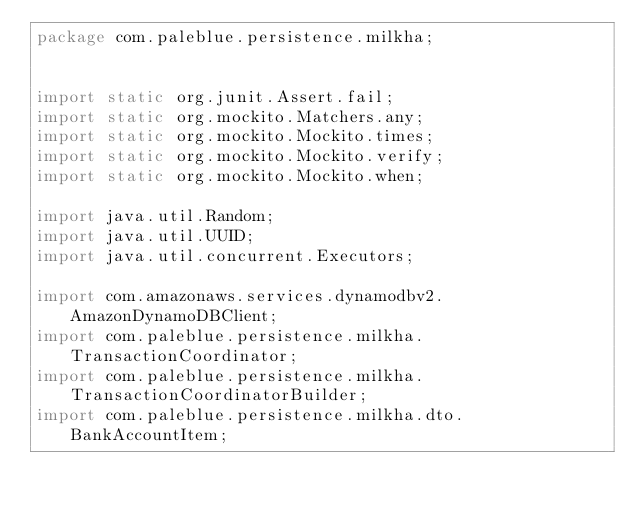<code> <loc_0><loc_0><loc_500><loc_500><_Java_>package com.paleblue.persistence.milkha;


import static org.junit.Assert.fail;
import static org.mockito.Matchers.any;
import static org.mockito.Mockito.times;
import static org.mockito.Mockito.verify;
import static org.mockito.Mockito.when;

import java.util.Random;
import java.util.UUID;
import java.util.concurrent.Executors;

import com.amazonaws.services.dynamodbv2.AmazonDynamoDBClient;
import com.paleblue.persistence.milkha.TransactionCoordinator;
import com.paleblue.persistence.milkha.TransactionCoordinatorBuilder;
import com.paleblue.persistence.milkha.dto.BankAccountItem;</code> 